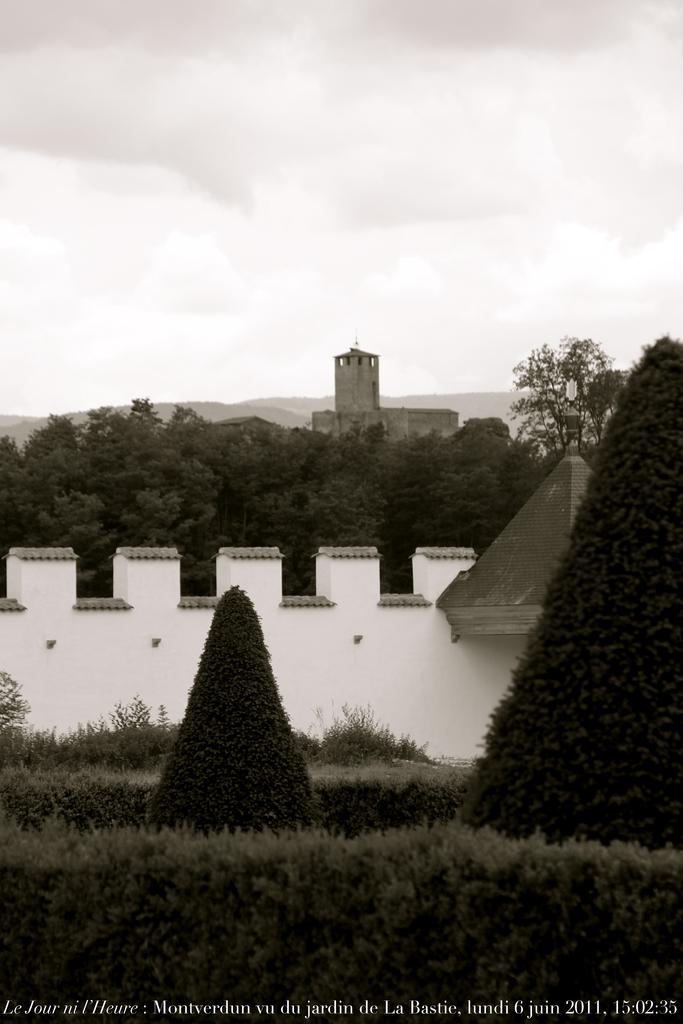What is the weather like in the image? The sky is cloudy in the image. What type of vegetation can be seen in the image? There are plants and trees in the image. What is the color of the wall in the image? There is a white wall in the image. What type of structure is present in the image? There is a building in the image. How does the judge hold the grip in the image? There is no judge or grip present in the image. What type of join can be seen connecting the trees in the image? There is no join connecting the trees in the image; they are separate entities. 